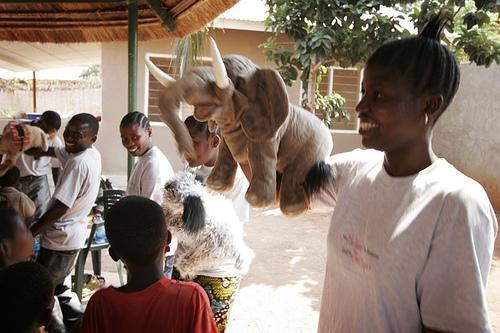How many children are holding an elephant puppet?
Give a very brief answer. 1. 